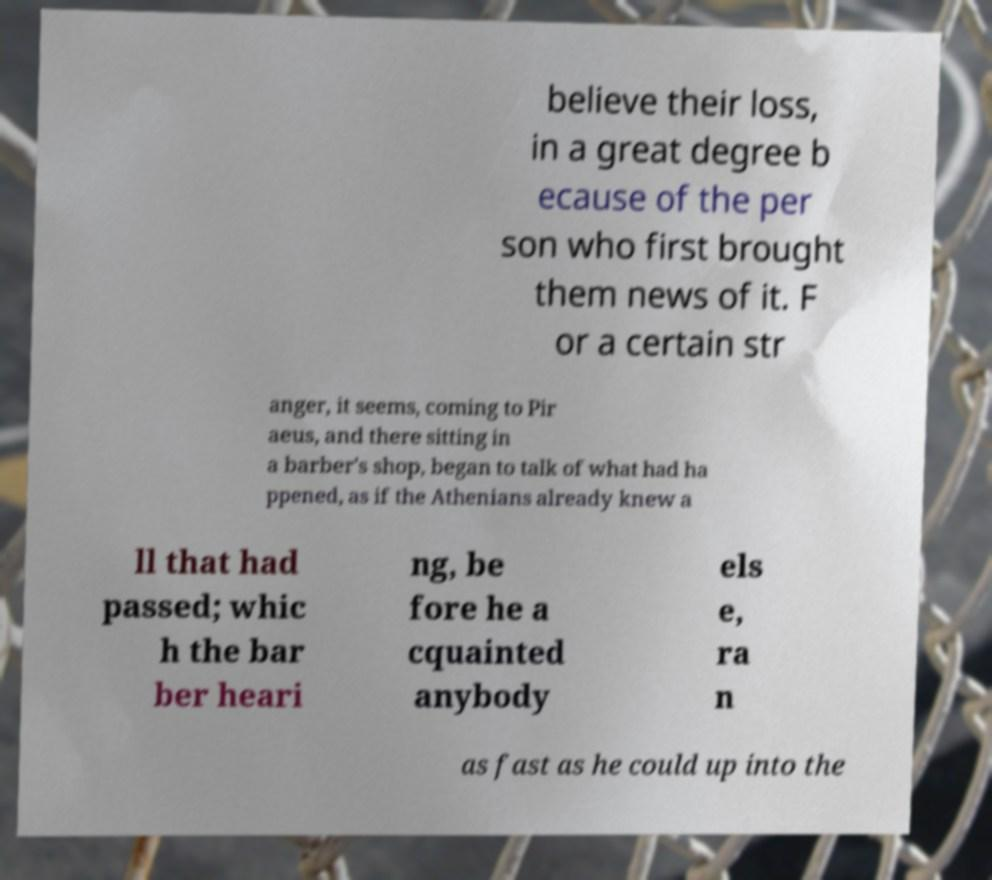There's text embedded in this image that I need extracted. Can you transcribe it verbatim? believe their loss, in a great degree b ecause of the per son who first brought them news of it. F or a certain str anger, it seems, coming to Pir aeus, and there sitting in a barber's shop, began to talk of what had ha ppened, as if the Athenians already knew a ll that had passed; whic h the bar ber heari ng, be fore he a cquainted anybody els e, ra n as fast as he could up into the 